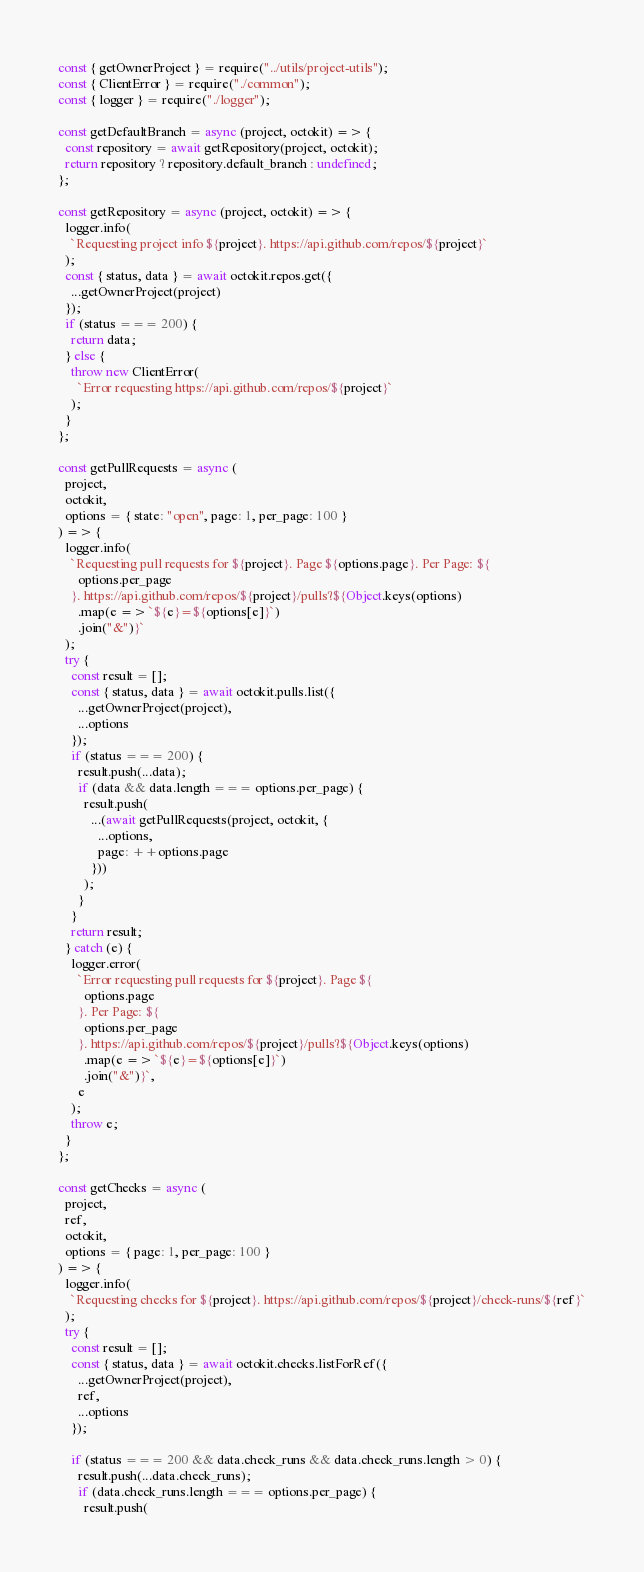<code> <loc_0><loc_0><loc_500><loc_500><_JavaScript_>const { getOwnerProject } = require("../utils/project-utils");
const { ClientError } = require("./common");
const { logger } = require("./logger");

const getDefaultBranch = async (project, octokit) => {
  const repository = await getRepository(project, octokit);
  return repository ? repository.default_branch : undefined;
};

const getRepository = async (project, octokit) => {
  logger.info(
    `Requesting project info ${project}. https://api.github.com/repos/${project}`
  );
  const { status, data } = await octokit.repos.get({
    ...getOwnerProject(project)
  });
  if (status === 200) {
    return data;
  } else {
    throw new ClientError(
      `Error requesting https://api.github.com/repos/${project}`
    );
  }
};

const getPullRequests = async (
  project,
  octokit,
  options = { state: "open", page: 1, per_page: 100 }
) => {
  logger.info(
    `Requesting pull requests for ${project}. Page ${options.page}. Per Page: ${
      options.per_page
    }. https://api.github.com/repos/${project}/pulls?${Object.keys(options)
      .map(e => `${e}=${options[e]}`)
      .join("&")}`
  );
  try {
    const result = [];
    const { status, data } = await octokit.pulls.list({
      ...getOwnerProject(project),
      ...options
    });
    if (status === 200) {
      result.push(...data);
      if (data && data.length === options.per_page) {
        result.push(
          ...(await getPullRequests(project, octokit, {
            ...options,
            page: ++options.page
          }))
        );
      }
    }
    return result;
  } catch (e) {
    logger.error(
      `Error requesting pull requests for ${project}. Page ${
        options.page
      }. Per Page: ${
        options.per_page
      }. https://api.github.com/repos/${project}/pulls?${Object.keys(options)
        .map(e => `${e}=${options[e]}`)
        .join("&")}`,
      e
    );
    throw e;
  }
};

const getChecks = async (
  project,
  ref,
  octokit,
  options = { page: 1, per_page: 100 }
) => {
  logger.info(
    `Requesting checks for ${project}. https://api.github.com/repos/${project}/check-runs/${ref}`
  );
  try {
    const result = [];
    const { status, data } = await octokit.checks.listForRef({
      ...getOwnerProject(project),
      ref,
      ...options
    });

    if (status === 200 && data.check_runs && data.check_runs.length > 0) {
      result.push(...data.check_runs);
      if (data.check_runs.length === options.per_page) {
        result.push(</code> 